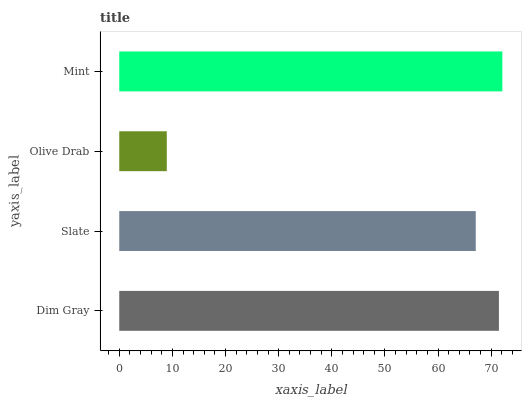Is Olive Drab the minimum?
Answer yes or no. Yes. Is Mint the maximum?
Answer yes or no. Yes. Is Slate the minimum?
Answer yes or no. No. Is Slate the maximum?
Answer yes or no. No. Is Dim Gray greater than Slate?
Answer yes or no. Yes. Is Slate less than Dim Gray?
Answer yes or no. Yes. Is Slate greater than Dim Gray?
Answer yes or no. No. Is Dim Gray less than Slate?
Answer yes or no. No. Is Dim Gray the high median?
Answer yes or no. Yes. Is Slate the low median?
Answer yes or no. Yes. Is Slate the high median?
Answer yes or no. No. Is Olive Drab the low median?
Answer yes or no. No. 